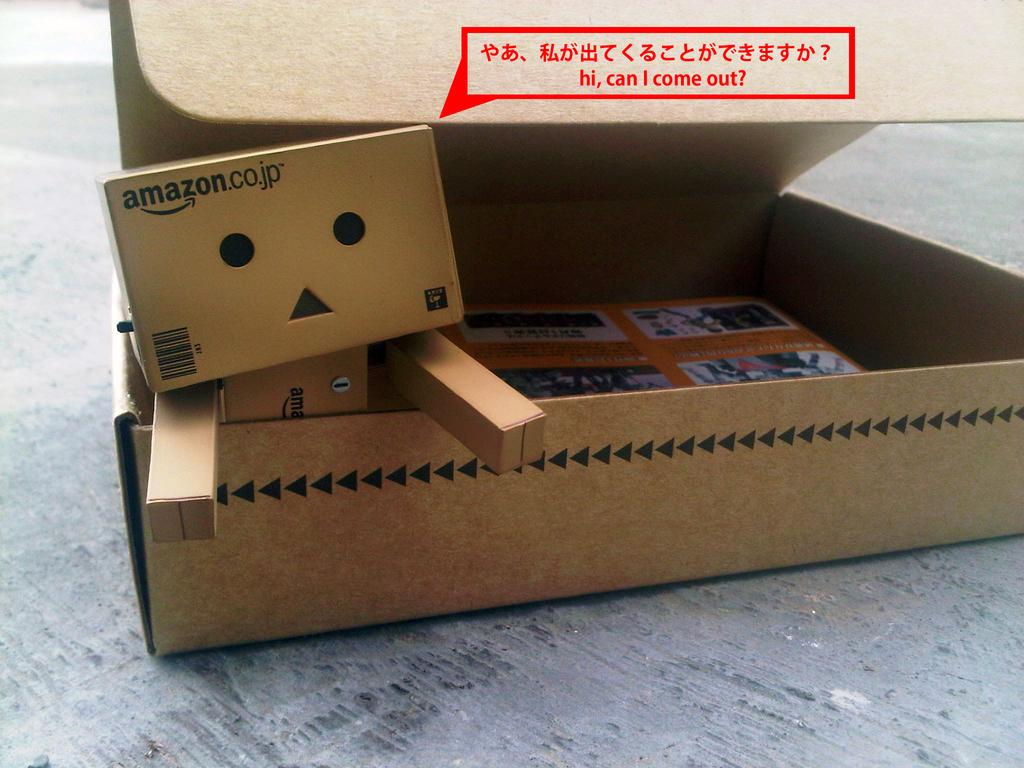<image>
Write a terse but informative summary of the picture. A box has the phrase can I  come out on the lid that is open. 